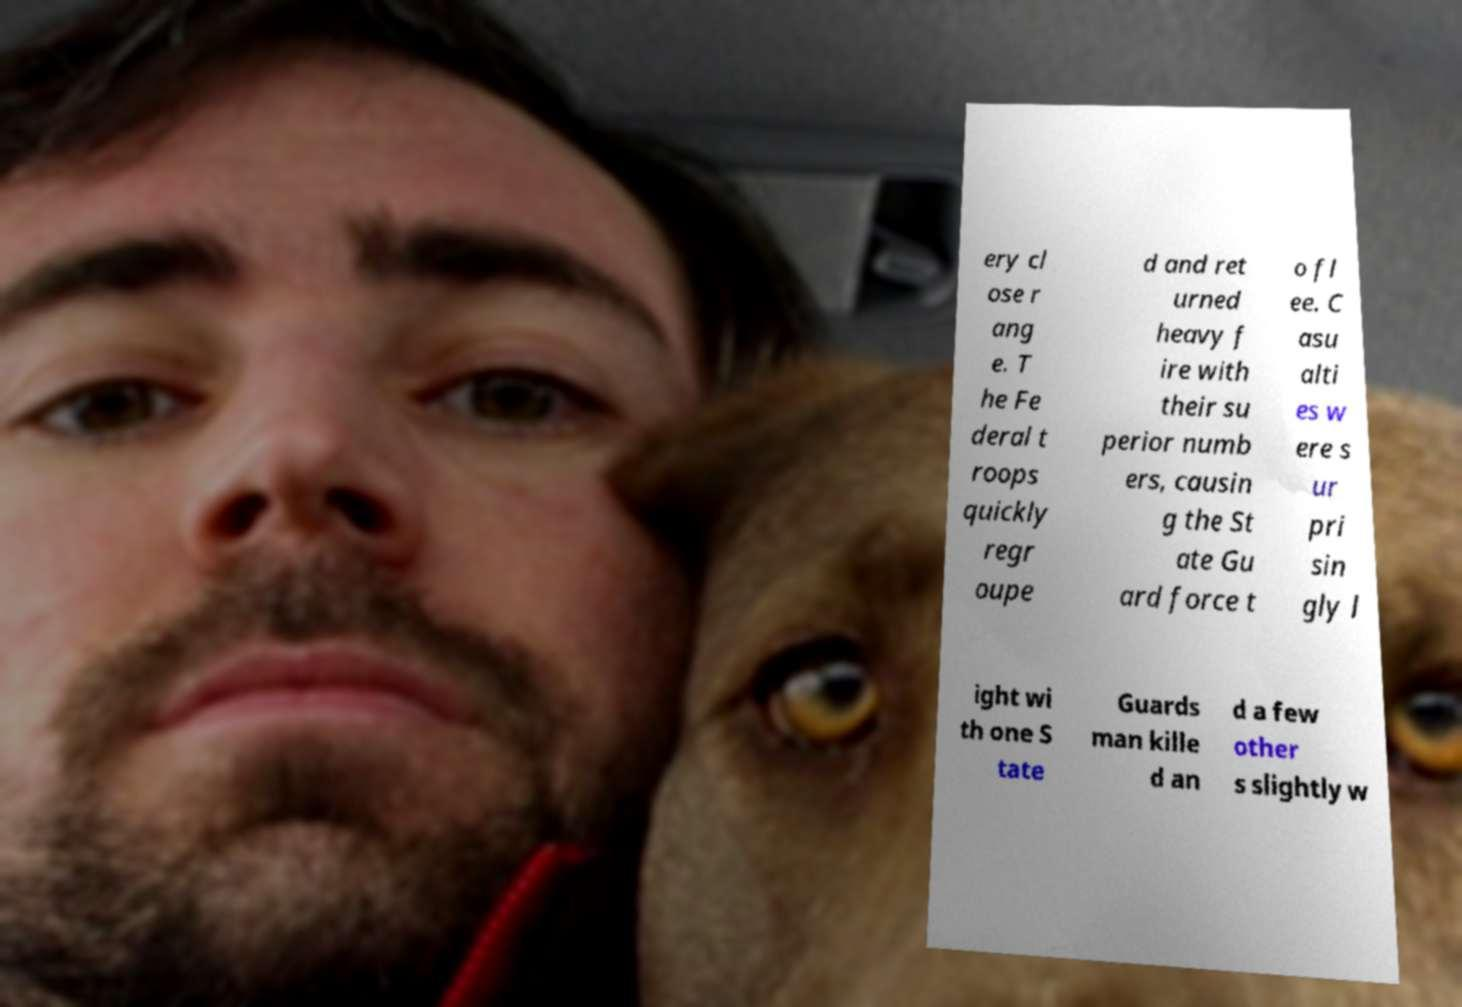I need the written content from this picture converted into text. Can you do that? ery cl ose r ang e. T he Fe deral t roops quickly regr oupe d and ret urned heavy f ire with their su perior numb ers, causin g the St ate Gu ard force t o fl ee. C asu alti es w ere s ur pri sin gly l ight wi th one S tate Guards man kille d an d a few other s slightly w 